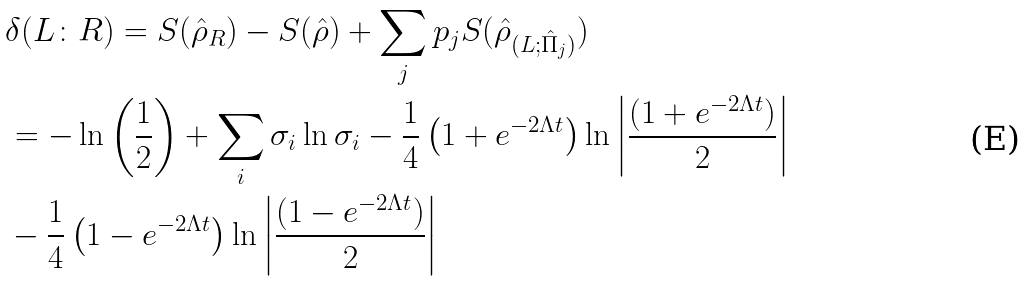<formula> <loc_0><loc_0><loc_500><loc_500>& \delta ( L \colon R ) = S ( \hat { \rho } _ { R } ) - S ( \hat { \rho } ) + \sum _ { j } p _ { j } S ( \hat { \rho } _ { ( L ; \hat { \Pi } _ { j } ) } ) \\ & = - \ln \left ( \frac { 1 } { 2 } \right ) + \sum _ { i } \sigma _ { i } \ln \sigma _ { i } - \frac { 1 } { 4 } \left ( 1 + e ^ { - 2 \Lambda t } \right ) \ln \left | \frac { ( 1 + e ^ { - 2 \Lambda t } ) } { 2 } \right | \\ & - \frac { 1 } { 4 } \left ( 1 - e ^ { - 2 \Lambda t } \right ) \ln \left | \frac { ( 1 - e ^ { - 2 \Lambda t } ) } { 2 } \right |</formula> 